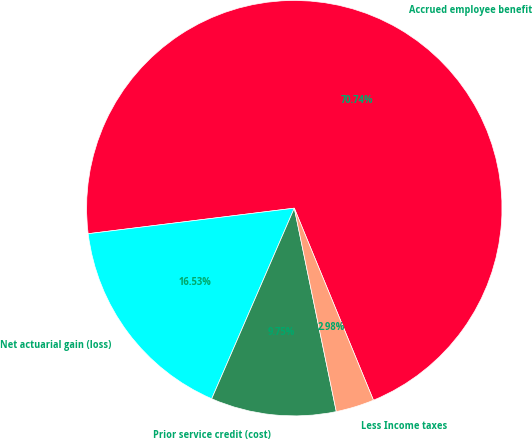<chart> <loc_0><loc_0><loc_500><loc_500><pie_chart><fcel>Accrued employee benefit<fcel>Net actuarial gain (loss)<fcel>Prior service credit (cost)<fcel>Less Income taxes<nl><fcel>70.74%<fcel>16.53%<fcel>9.75%<fcel>2.98%<nl></chart> 